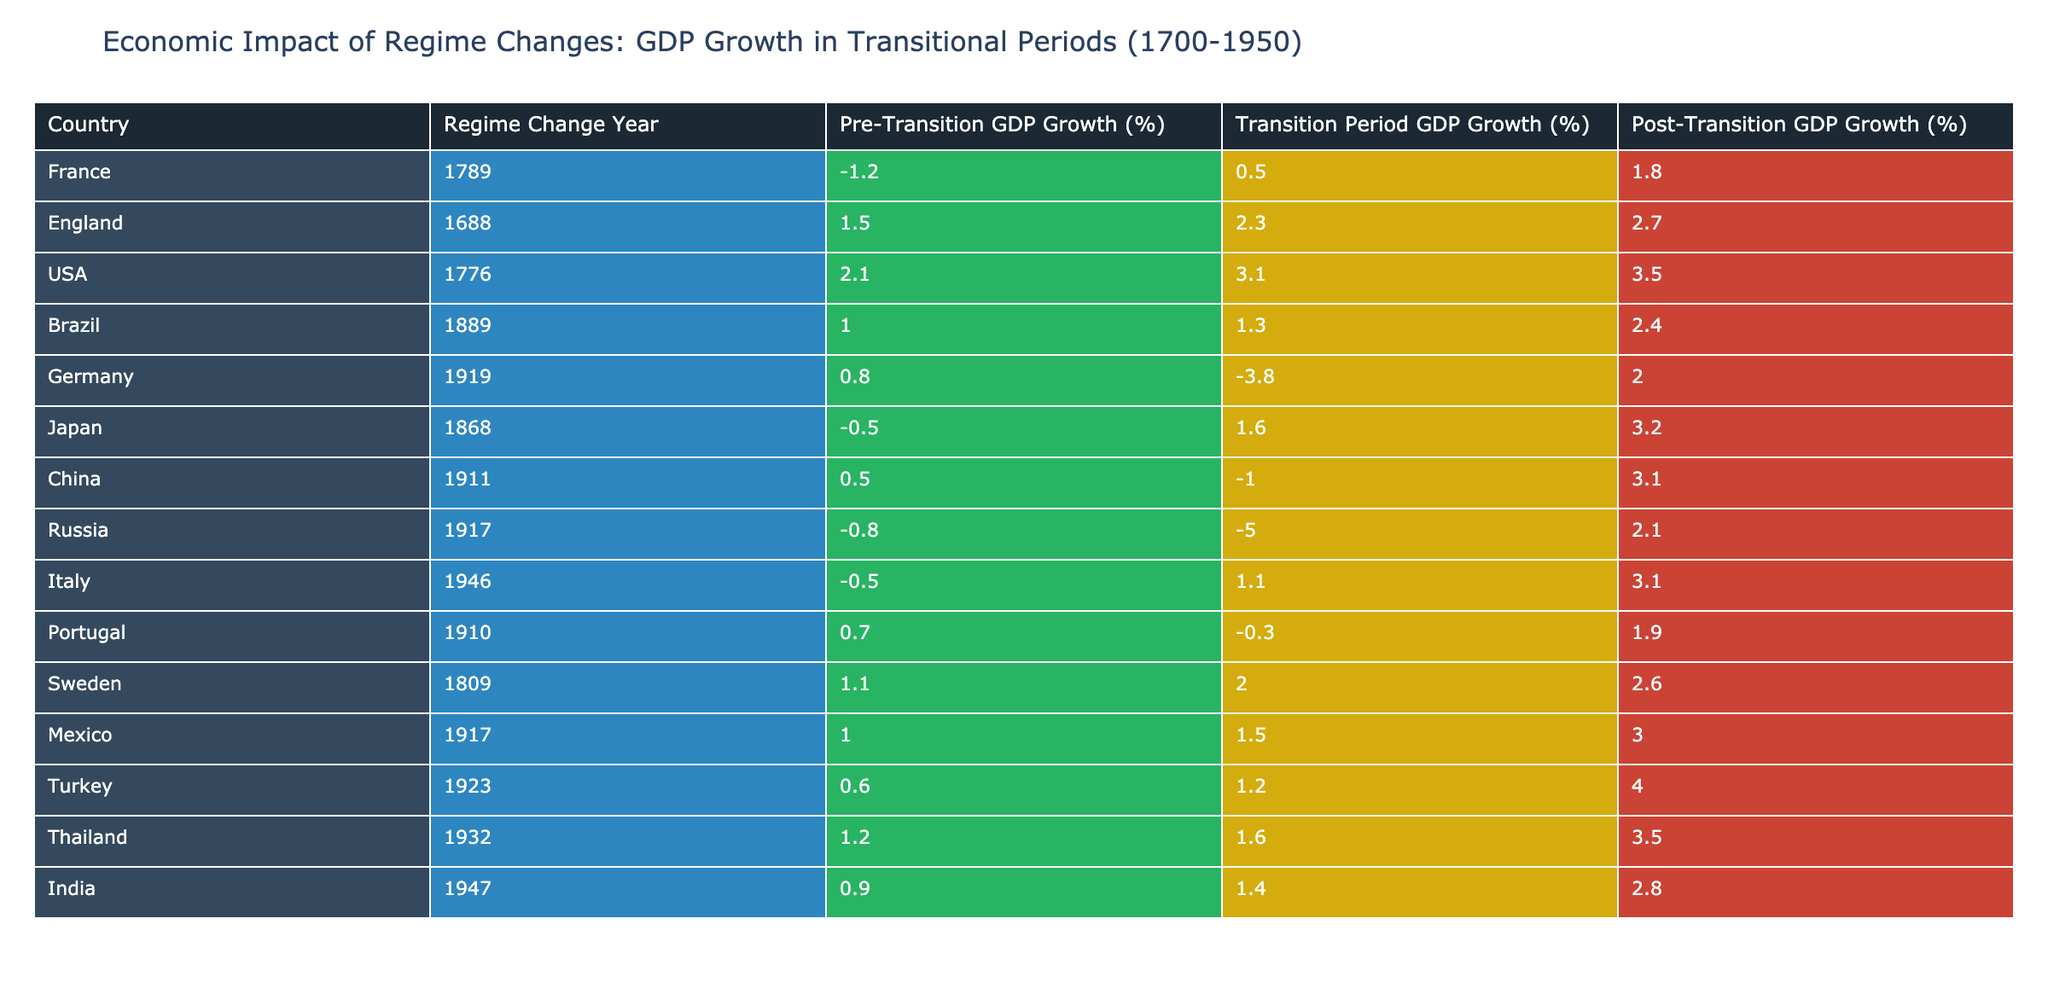What was the GDP growth rate for Germany during the Transition Period? Referring to the table, Germany's GDP growth rate during the Transition Period is listed as -3.8%.
Answer: -3.8 Which country experienced the highest Post-Transition GDP growth rate? Looking at the Post-Transition GDP growth rates across all countries, Turkey has the highest rate at 4.0%.
Answer: 4.0 What is the average Pre-Transition GDP growth rate for the countries listed? To find the average Pre-Transition GDP growth rate, sum the respective values (-1.2 + 1.5 + 2.1 + 1.0 + 0.8 + -0.5 + 0.5 + -0.8 + -0.5 + 0.7 + 1.1 + 1.0 + 0.6 + 1.2 + 0.9) = 7.2 and divide it by the number of countries (15). The average is 7.2/15 = 0.48%.
Answer: 0.48 Did any country show negative GDP growth during the Post-Transition period? By checking the Post-Transition GDP growth rates for all countries, we see that there are no negative values; therefore the answer is no.
Answer: No Which country had the largest difference between Pre-Transition and Transition Period GDP growth rates? The difference can be calculated for each country. For example, Germany has a difference of 4.6% (0.8 - (-3.8)) which is the highest among all the values reviewed.
Answer: 4.6% What was the GDP growth rate in the Transition Period for the USA? The table shows that the USA's GDP growth rate during the Transition Period is 3.1%.
Answer: 3.1 Which two countries showed an improvement from negative to positive GDP growth from the Transition Period to Post-Transition? By comparing the Transition and Post-Transition GDP growth rates, we find that both Japan (1.6 to 3.2) and Russia (-5.0 to 2.1) showed improvements.
Answer: Japan and Russia What is the GDP growth rate for Thailand during the Pre-Transition period? According to the table, Thailand's Pre-Transition GDP growth rate is 1.2%.
Answer: 1.2 What percentage of the listed countries had a Post-Transition GDP growth rate of 3% or higher? There are 15 countries listed, and 7 of them (USA, Japan, China, Italy, Mexico, Turkey, and Thailand) had a Post-Transition GDP growth rate of 3% or more. Thus, the percentage is (7/15) * 100 = 46.67%.
Answer: 46.67% 